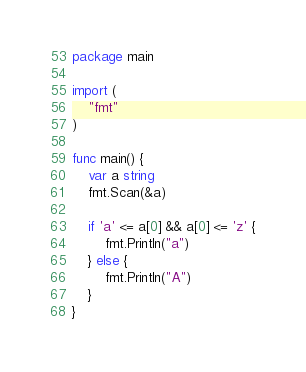Convert code to text. <code><loc_0><loc_0><loc_500><loc_500><_Go_>package main

import (
	"fmt"
)

func main() {
	var a string
	fmt.Scan(&a)

	if 'a' <= a[0] && a[0] <= 'z' {
		fmt.Println("a")
	} else {
		fmt.Println("A")
	}
}
</code> 